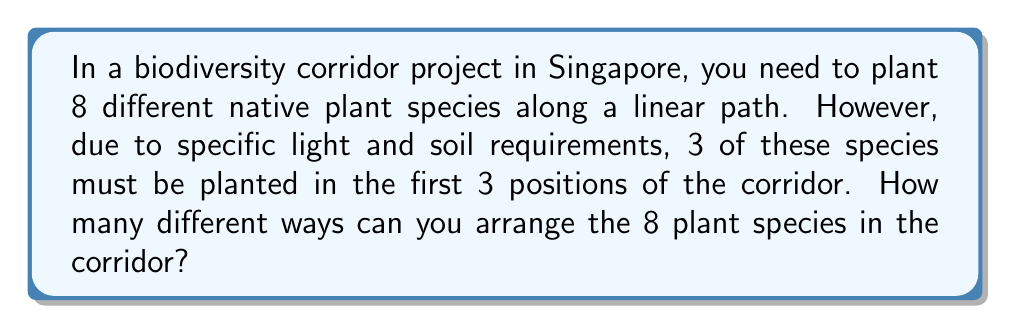Give your solution to this math problem. Let's approach this step-by-step:

1) First, we need to consider the 3 species that must be planted in the first 3 positions. These 3 species can be arranged among themselves in $3! = 3 \times 2 \times 1 = 6$ ways.

2) After placing these 3 species, we have 5 species left to arrange in the remaining 5 positions.

3) These 5 species can be arranged in $5! = 5 \times 4 \times 3 \times 2 \times 1 = 120$ ways.

4) By the multiplication principle, the total number of ways to arrange the plants is the product of the number of ways to arrange the first 3 plants and the number of ways to arrange the remaining 5 plants.

5) Therefore, the total number of permutations is:

   $$6 \times 120 = 720$$

This can also be expressed as:

$$3! \times 5! = 6 \times 120 = 720$$
Answer: 720 different arrangements 